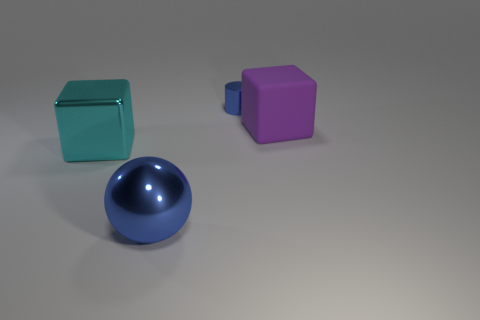What number of cylinders are either small gray matte things or small shiny objects?
Ensure brevity in your answer.  1. How many spheres are behind the block that is to the left of the tiny blue metal cylinder on the left side of the purple cube?
Offer a very short reply. 0. There is a thing that is the same color as the large sphere; what is its size?
Provide a succinct answer. Small. Is there a large cyan object made of the same material as the big sphere?
Ensure brevity in your answer.  Yes. Is the material of the large purple object the same as the large cyan cube?
Offer a terse response. No. How many balls are behind the blue shiny thing that is to the left of the blue metallic cylinder?
Give a very brief answer. 0. What number of blue objects are big metallic balls or tiny shiny cylinders?
Your answer should be very brief. 2. What shape is the metallic thing that is in front of the large cyan block that is behind the big metallic thing to the right of the big cyan metal thing?
Keep it short and to the point. Sphere. There is a sphere that is the same size as the cyan block; what is its color?
Give a very brief answer. Blue. What number of metal things are the same shape as the purple matte object?
Give a very brief answer. 1. 